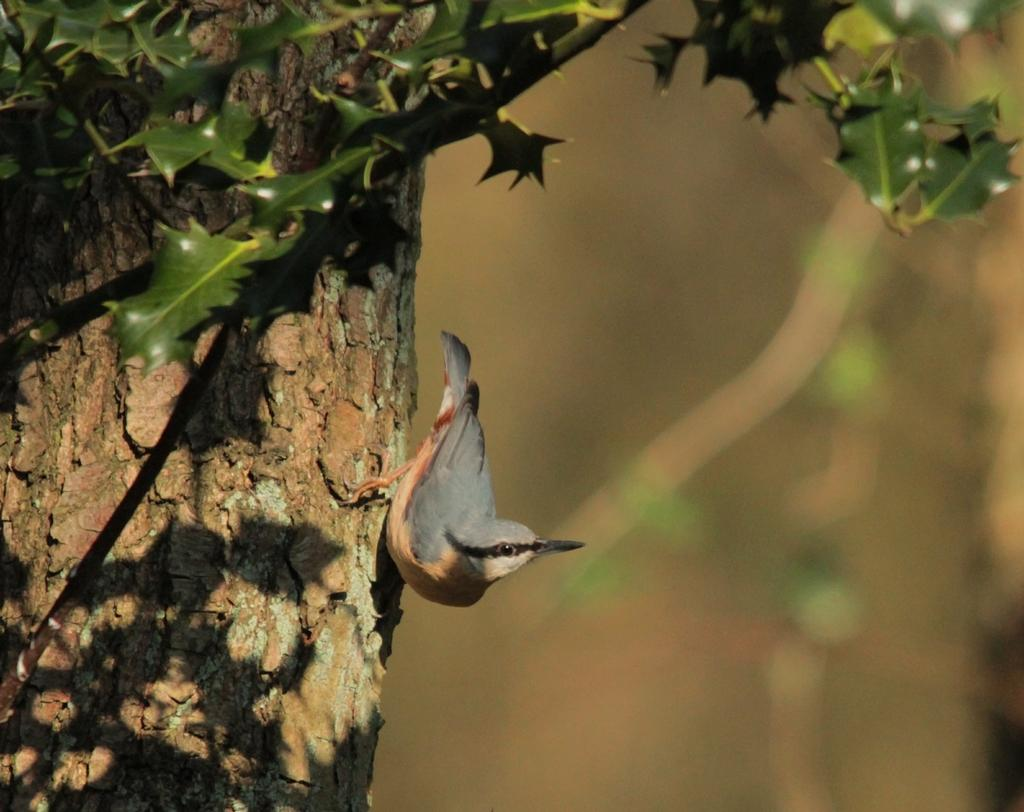What type of animal can be seen in the image? There is a bird in the image. Where is the bird located? The bird is on a tree. What is the position of the tree in the image? The tree is in the center of the image. What type of mask is the bird wearing in the image? There is no mask present on the bird in the image. What color is the orange fruit on the tree in the image? There is no orange fruit present on the tree in the image. 